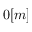<formula> <loc_0><loc_0><loc_500><loc_500>0 [ m ]</formula> 